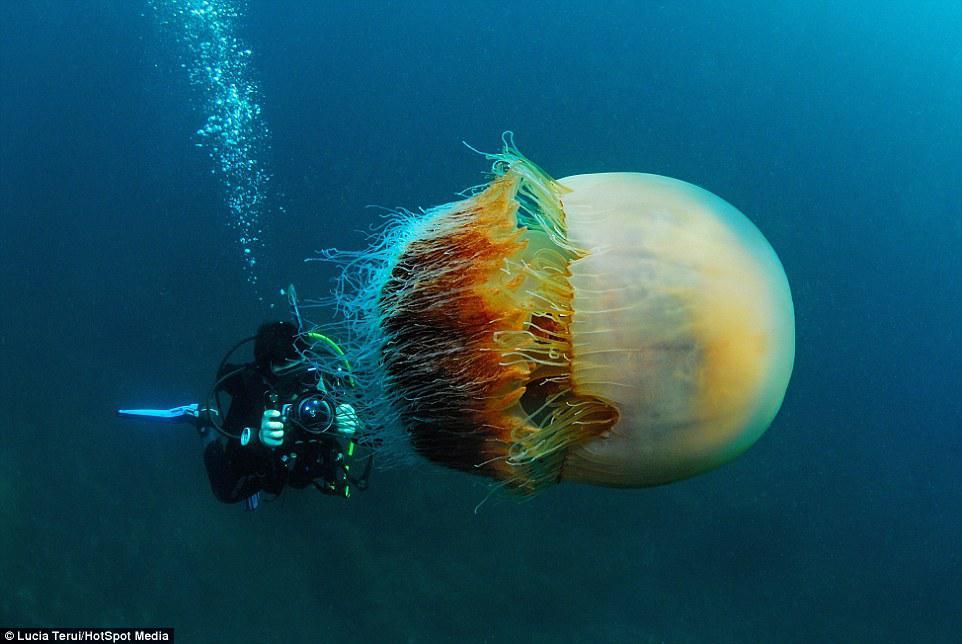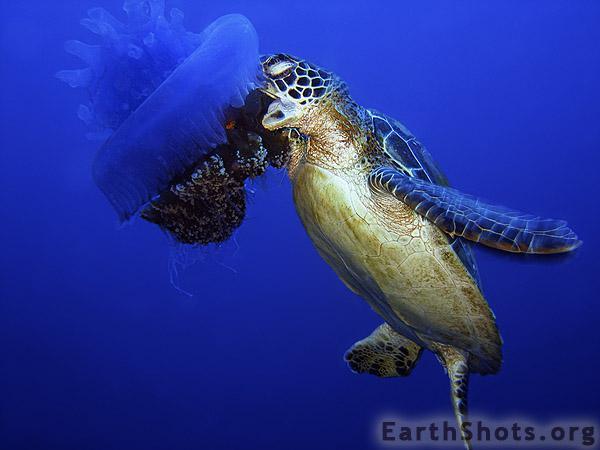The first image is the image on the left, the second image is the image on the right. Analyze the images presented: Is the assertion "There is at least one human visible." valid? Answer yes or no. Yes. The first image is the image on the left, the second image is the image on the right. Considering the images on both sides, is "One jellyfish has pink hues." valid? Answer yes or no. No. 